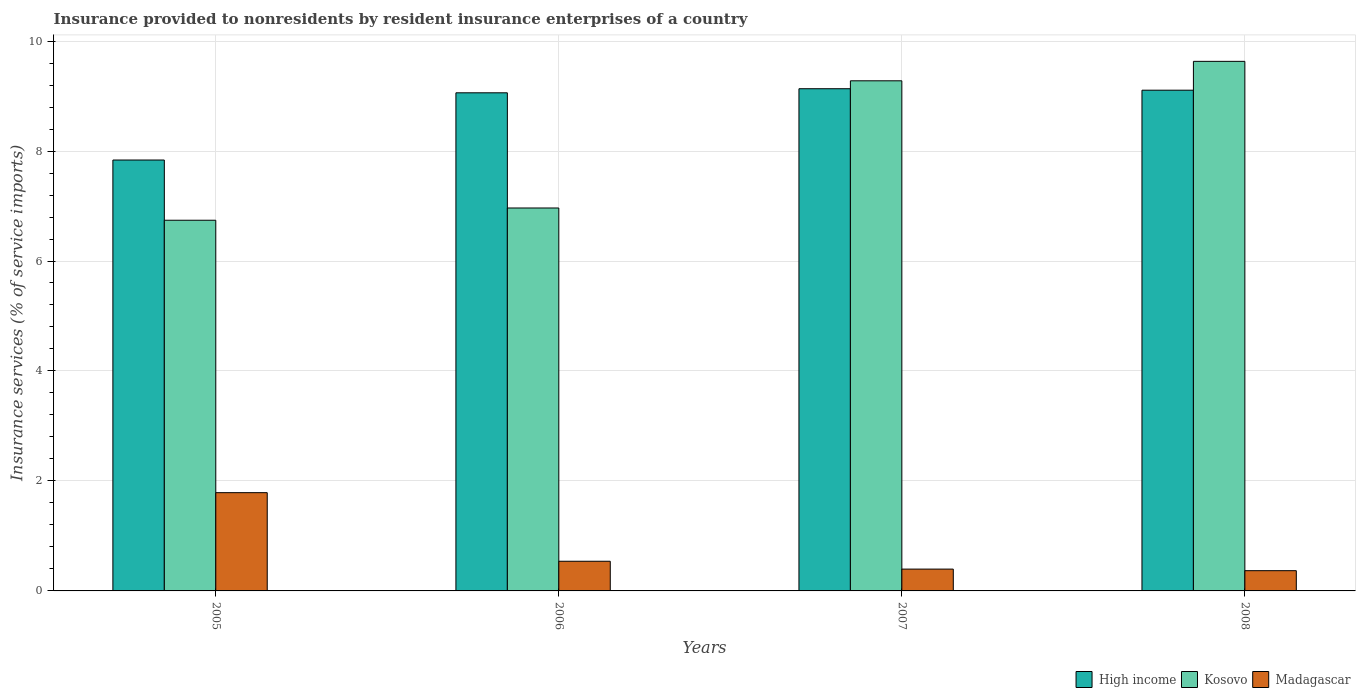Are the number of bars per tick equal to the number of legend labels?
Your answer should be very brief. Yes. How many bars are there on the 4th tick from the left?
Make the answer very short. 3. How many bars are there on the 3rd tick from the right?
Give a very brief answer. 3. What is the label of the 2nd group of bars from the left?
Provide a short and direct response. 2006. In how many cases, is the number of bars for a given year not equal to the number of legend labels?
Provide a succinct answer. 0. What is the insurance provided to nonresidents in Kosovo in 2005?
Give a very brief answer. 6.74. Across all years, what is the maximum insurance provided to nonresidents in Madagascar?
Ensure brevity in your answer.  1.79. Across all years, what is the minimum insurance provided to nonresidents in High income?
Keep it short and to the point. 7.84. In which year was the insurance provided to nonresidents in Kosovo maximum?
Your response must be concise. 2008. In which year was the insurance provided to nonresidents in High income minimum?
Give a very brief answer. 2005. What is the total insurance provided to nonresidents in Kosovo in the graph?
Your answer should be very brief. 32.61. What is the difference between the insurance provided to nonresidents in Madagascar in 2005 and that in 2006?
Give a very brief answer. 1.25. What is the difference between the insurance provided to nonresidents in High income in 2007 and the insurance provided to nonresidents in Madagascar in 2005?
Offer a terse response. 7.35. What is the average insurance provided to nonresidents in High income per year?
Your answer should be very brief. 8.78. In the year 2008, what is the difference between the insurance provided to nonresidents in Madagascar and insurance provided to nonresidents in High income?
Make the answer very short. -8.74. In how many years, is the insurance provided to nonresidents in Madagascar greater than 4 %?
Keep it short and to the point. 0. What is the ratio of the insurance provided to nonresidents in High income in 2005 to that in 2006?
Your answer should be very brief. 0.87. What is the difference between the highest and the second highest insurance provided to nonresidents in High income?
Give a very brief answer. 0.03. What is the difference between the highest and the lowest insurance provided to nonresidents in Madagascar?
Offer a very short reply. 1.42. Is the sum of the insurance provided to nonresidents in High income in 2005 and 2008 greater than the maximum insurance provided to nonresidents in Madagascar across all years?
Offer a terse response. Yes. What does the 2nd bar from the left in 2005 represents?
Your answer should be very brief. Kosovo. What does the 2nd bar from the right in 2008 represents?
Offer a terse response. Kosovo. How many bars are there?
Your answer should be very brief. 12. Are all the bars in the graph horizontal?
Provide a succinct answer. No. What is the difference between two consecutive major ticks on the Y-axis?
Keep it short and to the point. 2. Are the values on the major ticks of Y-axis written in scientific E-notation?
Give a very brief answer. No. Does the graph contain grids?
Give a very brief answer. Yes. Where does the legend appear in the graph?
Keep it short and to the point. Bottom right. How many legend labels are there?
Your response must be concise. 3. What is the title of the graph?
Provide a short and direct response. Insurance provided to nonresidents by resident insurance enterprises of a country. What is the label or title of the X-axis?
Your answer should be very brief. Years. What is the label or title of the Y-axis?
Ensure brevity in your answer.  Insurance services (% of service imports). What is the Insurance services (% of service imports) of High income in 2005?
Provide a short and direct response. 7.84. What is the Insurance services (% of service imports) of Kosovo in 2005?
Keep it short and to the point. 6.74. What is the Insurance services (% of service imports) in Madagascar in 2005?
Ensure brevity in your answer.  1.79. What is the Insurance services (% of service imports) in High income in 2006?
Make the answer very short. 9.06. What is the Insurance services (% of service imports) in Kosovo in 2006?
Your answer should be compact. 6.96. What is the Insurance services (% of service imports) in Madagascar in 2006?
Keep it short and to the point. 0.54. What is the Insurance services (% of service imports) of High income in 2007?
Provide a succinct answer. 9.13. What is the Insurance services (% of service imports) in Kosovo in 2007?
Provide a short and direct response. 9.28. What is the Insurance services (% of service imports) in Madagascar in 2007?
Give a very brief answer. 0.4. What is the Insurance services (% of service imports) of High income in 2008?
Keep it short and to the point. 9.11. What is the Insurance services (% of service imports) of Kosovo in 2008?
Offer a terse response. 9.63. What is the Insurance services (% of service imports) of Madagascar in 2008?
Your answer should be compact. 0.37. Across all years, what is the maximum Insurance services (% of service imports) in High income?
Make the answer very short. 9.13. Across all years, what is the maximum Insurance services (% of service imports) of Kosovo?
Your answer should be compact. 9.63. Across all years, what is the maximum Insurance services (% of service imports) of Madagascar?
Your answer should be compact. 1.79. Across all years, what is the minimum Insurance services (% of service imports) in High income?
Keep it short and to the point. 7.84. Across all years, what is the minimum Insurance services (% of service imports) in Kosovo?
Ensure brevity in your answer.  6.74. Across all years, what is the minimum Insurance services (% of service imports) of Madagascar?
Your response must be concise. 0.37. What is the total Insurance services (% of service imports) of High income in the graph?
Provide a short and direct response. 35.13. What is the total Insurance services (% of service imports) of Kosovo in the graph?
Provide a short and direct response. 32.61. What is the total Insurance services (% of service imports) of Madagascar in the graph?
Ensure brevity in your answer.  3.09. What is the difference between the Insurance services (% of service imports) in High income in 2005 and that in 2006?
Offer a very short reply. -1.22. What is the difference between the Insurance services (% of service imports) of Kosovo in 2005 and that in 2006?
Your response must be concise. -0.22. What is the difference between the Insurance services (% of service imports) in Madagascar in 2005 and that in 2006?
Provide a succinct answer. 1.25. What is the difference between the Insurance services (% of service imports) in High income in 2005 and that in 2007?
Offer a terse response. -1.3. What is the difference between the Insurance services (% of service imports) of Kosovo in 2005 and that in 2007?
Your answer should be compact. -2.54. What is the difference between the Insurance services (% of service imports) of Madagascar in 2005 and that in 2007?
Make the answer very short. 1.39. What is the difference between the Insurance services (% of service imports) in High income in 2005 and that in 2008?
Your answer should be very brief. -1.27. What is the difference between the Insurance services (% of service imports) of Kosovo in 2005 and that in 2008?
Your answer should be very brief. -2.89. What is the difference between the Insurance services (% of service imports) in Madagascar in 2005 and that in 2008?
Provide a succinct answer. 1.42. What is the difference between the Insurance services (% of service imports) in High income in 2006 and that in 2007?
Your response must be concise. -0.07. What is the difference between the Insurance services (% of service imports) of Kosovo in 2006 and that in 2007?
Offer a very short reply. -2.31. What is the difference between the Insurance services (% of service imports) of Madagascar in 2006 and that in 2007?
Offer a terse response. 0.14. What is the difference between the Insurance services (% of service imports) of High income in 2006 and that in 2008?
Provide a succinct answer. -0.05. What is the difference between the Insurance services (% of service imports) in Kosovo in 2006 and that in 2008?
Offer a very short reply. -2.67. What is the difference between the Insurance services (% of service imports) in Madagascar in 2006 and that in 2008?
Ensure brevity in your answer.  0.17. What is the difference between the Insurance services (% of service imports) in High income in 2007 and that in 2008?
Your answer should be very brief. 0.03. What is the difference between the Insurance services (% of service imports) of Kosovo in 2007 and that in 2008?
Ensure brevity in your answer.  -0.35. What is the difference between the Insurance services (% of service imports) in Madagascar in 2007 and that in 2008?
Provide a short and direct response. 0.03. What is the difference between the Insurance services (% of service imports) of High income in 2005 and the Insurance services (% of service imports) of Kosovo in 2006?
Ensure brevity in your answer.  0.87. What is the difference between the Insurance services (% of service imports) of High income in 2005 and the Insurance services (% of service imports) of Madagascar in 2006?
Keep it short and to the point. 7.3. What is the difference between the Insurance services (% of service imports) in Kosovo in 2005 and the Insurance services (% of service imports) in Madagascar in 2006?
Your answer should be very brief. 6.2. What is the difference between the Insurance services (% of service imports) in High income in 2005 and the Insurance services (% of service imports) in Kosovo in 2007?
Your response must be concise. -1.44. What is the difference between the Insurance services (% of service imports) of High income in 2005 and the Insurance services (% of service imports) of Madagascar in 2007?
Make the answer very short. 7.44. What is the difference between the Insurance services (% of service imports) in Kosovo in 2005 and the Insurance services (% of service imports) in Madagascar in 2007?
Offer a very short reply. 6.34. What is the difference between the Insurance services (% of service imports) in High income in 2005 and the Insurance services (% of service imports) in Kosovo in 2008?
Keep it short and to the point. -1.79. What is the difference between the Insurance services (% of service imports) in High income in 2005 and the Insurance services (% of service imports) in Madagascar in 2008?
Your answer should be very brief. 7.47. What is the difference between the Insurance services (% of service imports) of Kosovo in 2005 and the Insurance services (% of service imports) of Madagascar in 2008?
Give a very brief answer. 6.37. What is the difference between the Insurance services (% of service imports) of High income in 2006 and the Insurance services (% of service imports) of Kosovo in 2007?
Your response must be concise. -0.22. What is the difference between the Insurance services (% of service imports) in High income in 2006 and the Insurance services (% of service imports) in Madagascar in 2007?
Ensure brevity in your answer.  8.66. What is the difference between the Insurance services (% of service imports) in Kosovo in 2006 and the Insurance services (% of service imports) in Madagascar in 2007?
Your answer should be compact. 6.57. What is the difference between the Insurance services (% of service imports) of High income in 2006 and the Insurance services (% of service imports) of Kosovo in 2008?
Provide a succinct answer. -0.57. What is the difference between the Insurance services (% of service imports) in High income in 2006 and the Insurance services (% of service imports) in Madagascar in 2008?
Give a very brief answer. 8.69. What is the difference between the Insurance services (% of service imports) of Kosovo in 2006 and the Insurance services (% of service imports) of Madagascar in 2008?
Offer a terse response. 6.6. What is the difference between the Insurance services (% of service imports) in High income in 2007 and the Insurance services (% of service imports) in Kosovo in 2008?
Make the answer very short. -0.5. What is the difference between the Insurance services (% of service imports) in High income in 2007 and the Insurance services (% of service imports) in Madagascar in 2008?
Offer a terse response. 8.76. What is the difference between the Insurance services (% of service imports) of Kosovo in 2007 and the Insurance services (% of service imports) of Madagascar in 2008?
Ensure brevity in your answer.  8.91. What is the average Insurance services (% of service imports) in High income per year?
Offer a terse response. 8.78. What is the average Insurance services (% of service imports) of Kosovo per year?
Give a very brief answer. 8.15. What is the average Insurance services (% of service imports) of Madagascar per year?
Provide a succinct answer. 0.77. In the year 2005, what is the difference between the Insurance services (% of service imports) in High income and Insurance services (% of service imports) in Kosovo?
Offer a terse response. 1.1. In the year 2005, what is the difference between the Insurance services (% of service imports) of High income and Insurance services (% of service imports) of Madagascar?
Make the answer very short. 6.05. In the year 2005, what is the difference between the Insurance services (% of service imports) of Kosovo and Insurance services (% of service imports) of Madagascar?
Offer a terse response. 4.95. In the year 2006, what is the difference between the Insurance services (% of service imports) in High income and Insurance services (% of service imports) in Kosovo?
Your response must be concise. 2.09. In the year 2006, what is the difference between the Insurance services (% of service imports) in High income and Insurance services (% of service imports) in Madagascar?
Provide a short and direct response. 8.52. In the year 2006, what is the difference between the Insurance services (% of service imports) of Kosovo and Insurance services (% of service imports) of Madagascar?
Your answer should be compact. 6.42. In the year 2007, what is the difference between the Insurance services (% of service imports) of High income and Insurance services (% of service imports) of Kosovo?
Make the answer very short. -0.14. In the year 2007, what is the difference between the Insurance services (% of service imports) in High income and Insurance services (% of service imports) in Madagascar?
Keep it short and to the point. 8.74. In the year 2007, what is the difference between the Insurance services (% of service imports) of Kosovo and Insurance services (% of service imports) of Madagascar?
Your answer should be very brief. 8.88. In the year 2008, what is the difference between the Insurance services (% of service imports) of High income and Insurance services (% of service imports) of Kosovo?
Offer a very short reply. -0.52. In the year 2008, what is the difference between the Insurance services (% of service imports) in High income and Insurance services (% of service imports) in Madagascar?
Make the answer very short. 8.74. In the year 2008, what is the difference between the Insurance services (% of service imports) in Kosovo and Insurance services (% of service imports) in Madagascar?
Give a very brief answer. 9.26. What is the ratio of the Insurance services (% of service imports) of High income in 2005 to that in 2006?
Provide a short and direct response. 0.87. What is the ratio of the Insurance services (% of service imports) of Madagascar in 2005 to that in 2006?
Your answer should be very brief. 3.31. What is the ratio of the Insurance services (% of service imports) of High income in 2005 to that in 2007?
Offer a terse response. 0.86. What is the ratio of the Insurance services (% of service imports) of Kosovo in 2005 to that in 2007?
Give a very brief answer. 0.73. What is the ratio of the Insurance services (% of service imports) of Madagascar in 2005 to that in 2007?
Your response must be concise. 4.5. What is the ratio of the Insurance services (% of service imports) in High income in 2005 to that in 2008?
Your answer should be compact. 0.86. What is the ratio of the Insurance services (% of service imports) of Madagascar in 2005 to that in 2008?
Make the answer very short. 4.85. What is the ratio of the Insurance services (% of service imports) in Kosovo in 2006 to that in 2007?
Offer a terse response. 0.75. What is the ratio of the Insurance services (% of service imports) in Madagascar in 2006 to that in 2007?
Ensure brevity in your answer.  1.36. What is the ratio of the Insurance services (% of service imports) in Kosovo in 2006 to that in 2008?
Your answer should be compact. 0.72. What is the ratio of the Insurance services (% of service imports) in Madagascar in 2006 to that in 2008?
Offer a terse response. 1.47. What is the ratio of the Insurance services (% of service imports) of High income in 2007 to that in 2008?
Offer a terse response. 1. What is the ratio of the Insurance services (% of service imports) in Kosovo in 2007 to that in 2008?
Offer a very short reply. 0.96. What is the ratio of the Insurance services (% of service imports) in Madagascar in 2007 to that in 2008?
Ensure brevity in your answer.  1.08. What is the difference between the highest and the second highest Insurance services (% of service imports) of High income?
Keep it short and to the point. 0.03. What is the difference between the highest and the second highest Insurance services (% of service imports) in Kosovo?
Keep it short and to the point. 0.35. What is the difference between the highest and the second highest Insurance services (% of service imports) in Madagascar?
Provide a short and direct response. 1.25. What is the difference between the highest and the lowest Insurance services (% of service imports) of High income?
Keep it short and to the point. 1.3. What is the difference between the highest and the lowest Insurance services (% of service imports) of Kosovo?
Provide a short and direct response. 2.89. What is the difference between the highest and the lowest Insurance services (% of service imports) in Madagascar?
Offer a terse response. 1.42. 